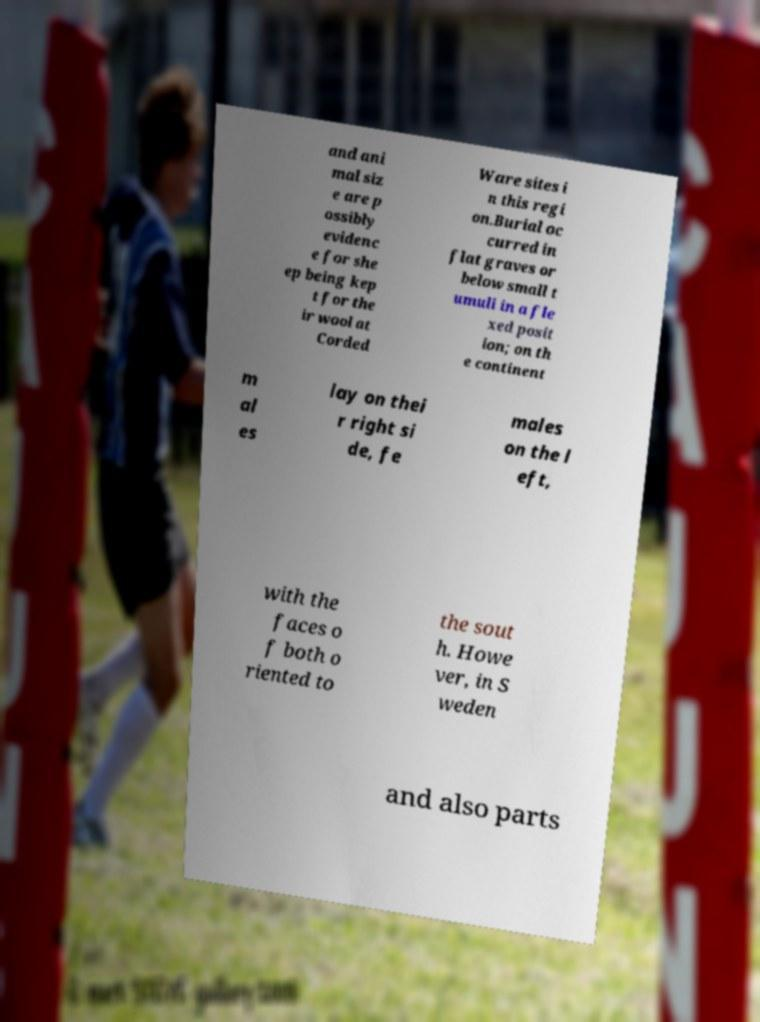Could you assist in decoding the text presented in this image and type it out clearly? and ani mal siz e are p ossibly evidenc e for she ep being kep t for the ir wool at Corded Ware sites i n this regi on.Burial oc curred in flat graves or below small t umuli in a fle xed posit ion; on th e continent m al es lay on thei r right si de, fe males on the l eft, with the faces o f both o riented to the sout h. Howe ver, in S weden and also parts 